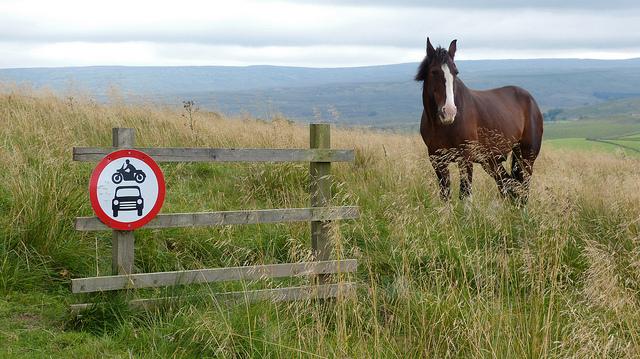What IS PICTURED ON THE WARNING SIGN BESIDES A CAR?
Give a very brief answer. Motorcycle. How many horses are in the picture?
Answer briefly. 1. Is the horse a pet?
Concise answer only. Yes. 